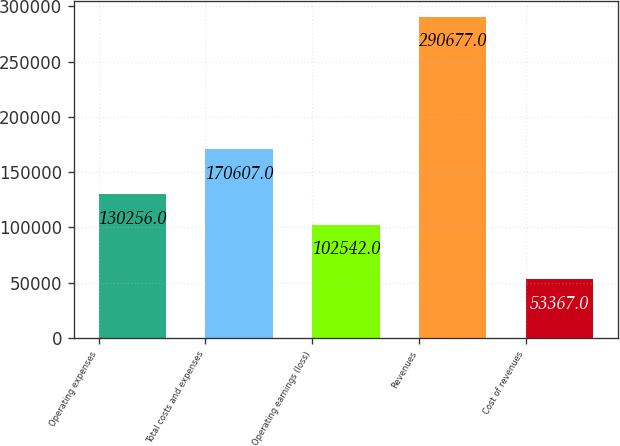Convert chart. <chart><loc_0><loc_0><loc_500><loc_500><bar_chart><fcel>Operating expenses<fcel>Total costs and expenses<fcel>Operating earnings (loss)<fcel>Revenues<fcel>Cost of revenues<nl><fcel>130256<fcel>170607<fcel>102542<fcel>290677<fcel>53367<nl></chart> 